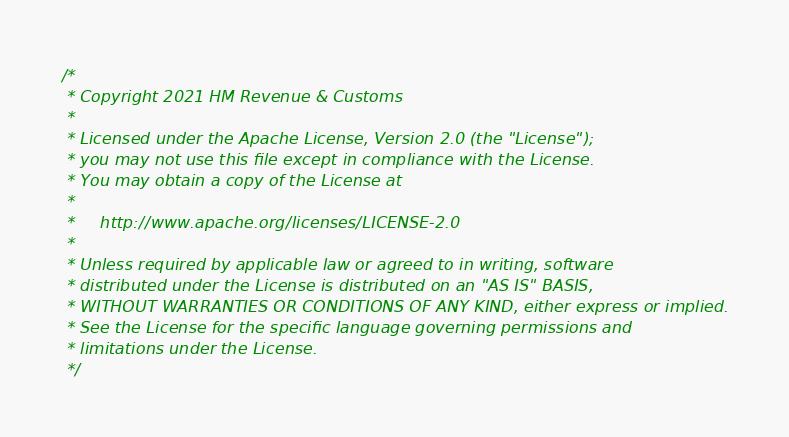Convert code to text. <code><loc_0><loc_0><loc_500><loc_500><_Scala_>/*
 * Copyright 2021 HM Revenue & Customs
 *
 * Licensed under the Apache License, Version 2.0 (the "License");
 * you may not use this file except in compliance with the License.
 * You may obtain a copy of the License at
 *
 *     http://www.apache.org/licenses/LICENSE-2.0
 *
 * Unless required by applicable law or agreed to in writing, software
 * distributed under the License is distributed on an "AS IS" BASIS,
 * WITHOUT WARRANTIES OR CONDITIONS OF ANY KIND, either express or implied.
 * See the License for the specific language governing permissions and
 * limitations under the License.
 */
</code> 